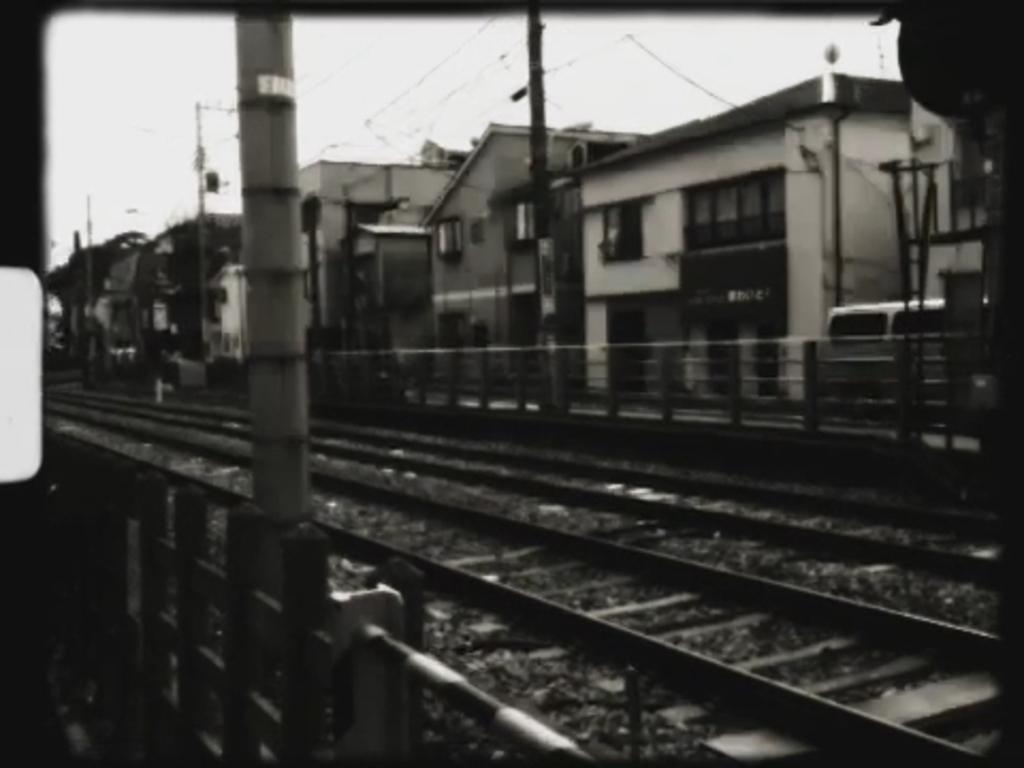Can you describe this image briefly? In this picture we can see railway tracks, beside these railway tracks we can see fences, buildings, vehicle, poles, sky and some objects. 